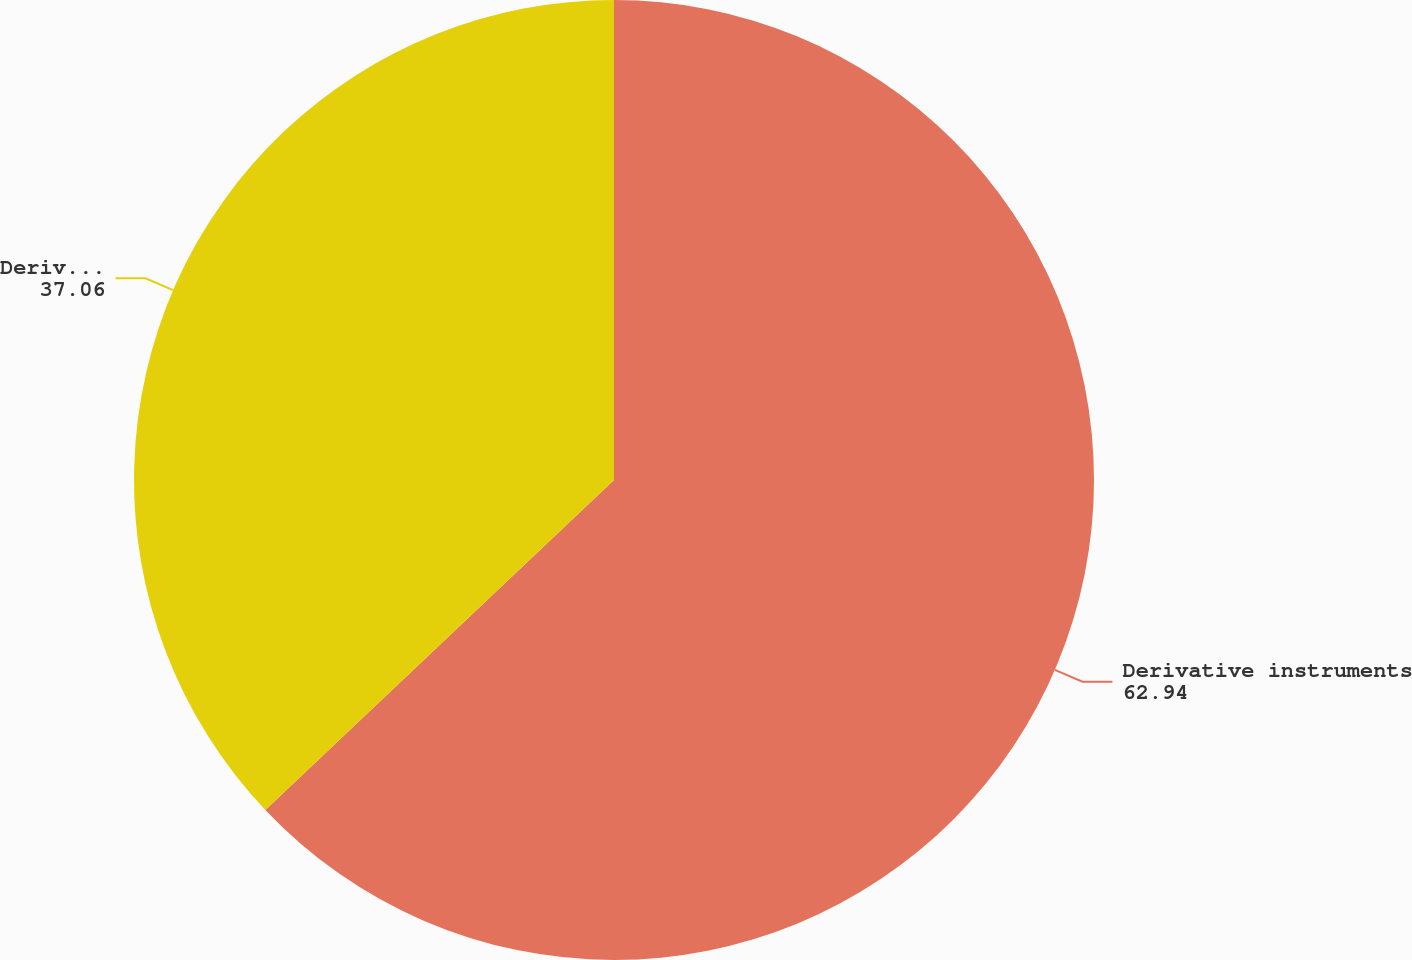<chart> <loc_0><loc_0><loc_500><loc_500><pie_chart><fcel>Derivative instruments<fcel>Derivative instruments(current<nl><fcel>62.94%<fcel>37.06%<nl></chart> 